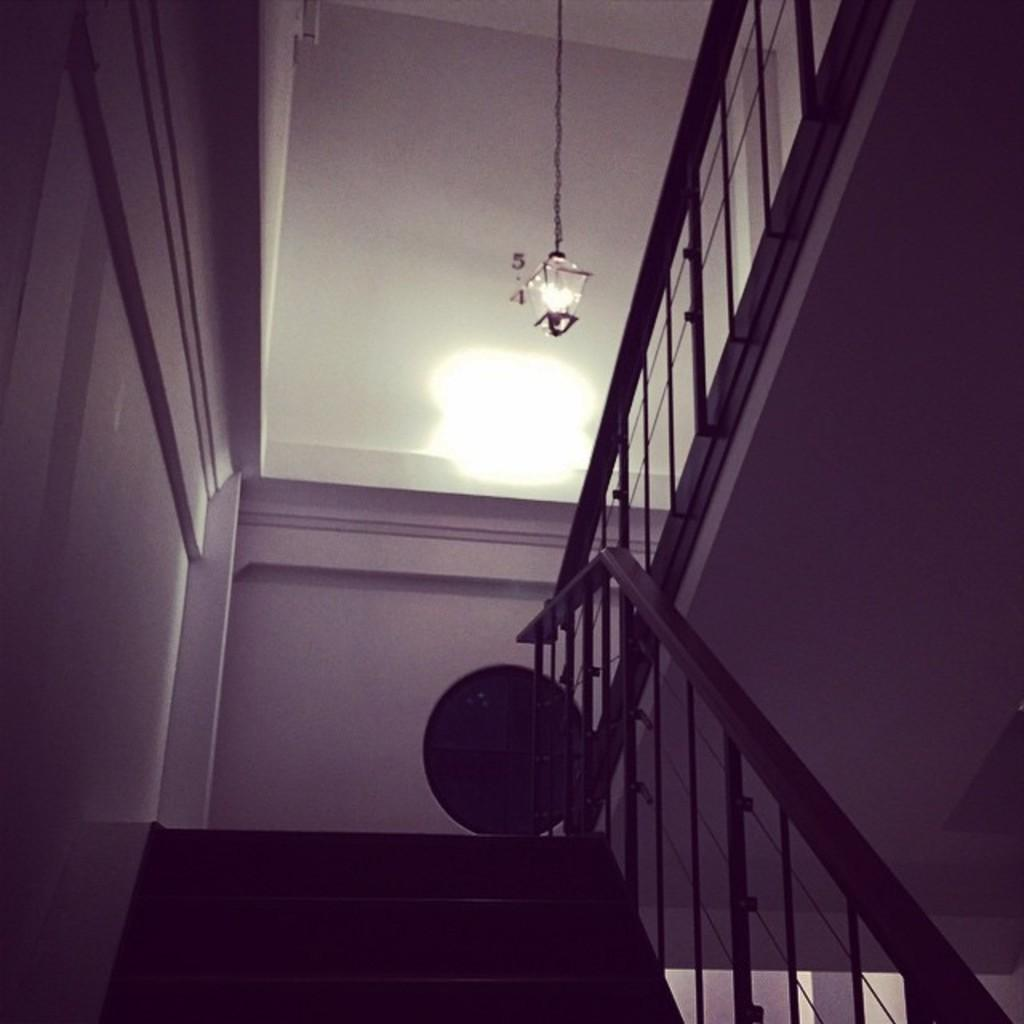Where was the image taken? The image was taken in a building. What architectural feature can be seen in the image? There is a staircase in the image. What lighting source is present in the image? There is a lamp in the image. Can you describe the object in the image? There is an object in the image, but its specific details are not mentioned in the facts. What color is the wall in the image? The wall in the image is painted white. What type of camera is used to take the picture of the town in the image? There is no town or camera present in the image; it is taken in a building with a staircase, lamp, and white wall. 